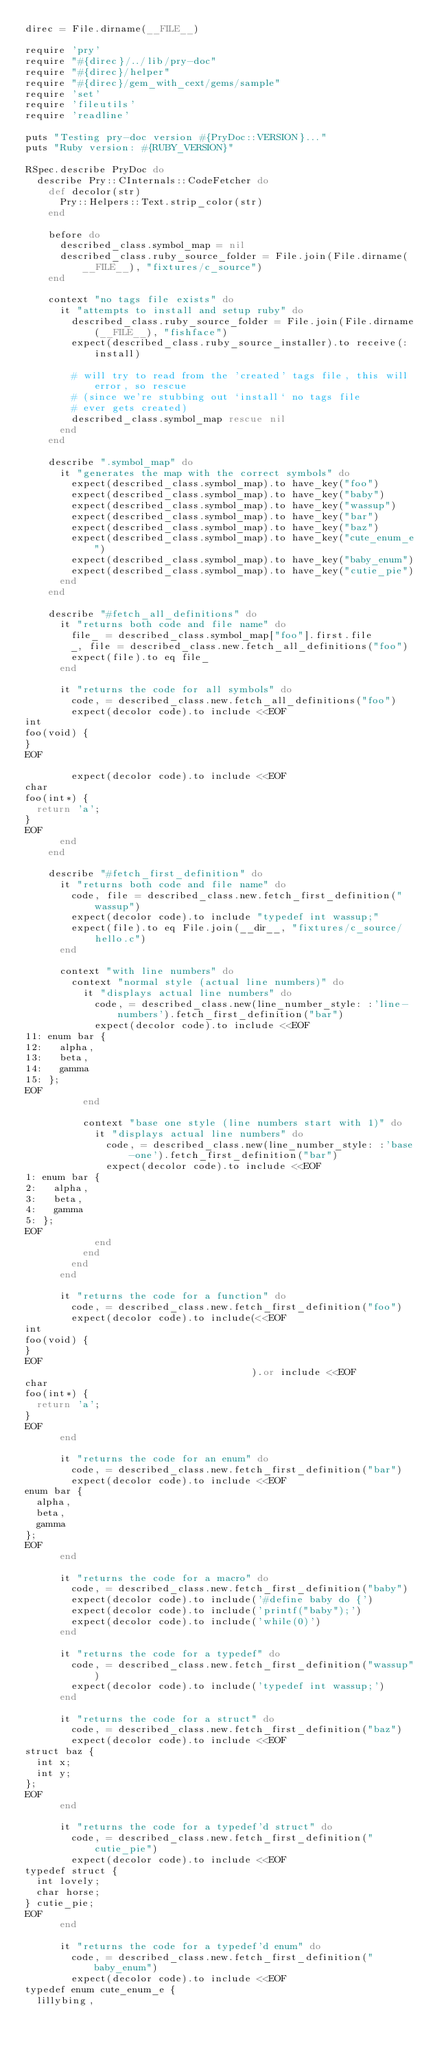<code> <loc_0><loc_0><loc_500><loc_500><_Ruby_>direc = File.dirname(__FILE__)

require 'pry'
require "#{direc}/../lib/pry-doc"
require "#{direc}/helper"
require "#{direc}/gem_with_cext/gems/sample"
require 'set'
require 'fileutils'
require 'readline'

puts "Testing pry-doc version #{PryDoc::VERSION}..."
puts "Ruby version: #{RUBY_VERSION}"

RSpec.describe PryDoc do
  describe Pry::CInternals::CodeFetcher do
    def decolor(str)
      Pry::Helpers::Text.strip_color(str)
    end

    before do
      described_class.symbol_map = nil
      described_class.ruby_source_folder = File.join(File.dirname(__FILE__), "fixtures/c_source")
    end

    context "no tags file exists" do
      it "attempts to install and setup ruby" do
        described_class.ruby_source_folder = File.join(File.dirname(__FILE__), "fishface")
        expect(described_class.ruby_source_installer).to receive(:install)

        # will try to read from the 'created' tags file, this will error, so rescue
        # (since we're stubbing out `install` no tags file
        # ever gets created)
        described_class.symbol_map rescue nil
      end
    end

    describe ".symbol_map" do
      it "generates the map with the correct symbols" do
        expect(described_class.symbol_map).to have_key("foo")
        expect(described_class.symbol_map).to have_key("baby")
        expect(described_class.symbol_map).to have_key("wassup")
        expect(described_class.symbol_map).to have_key("bar")
        expect(described_class.symbol_map).to have_key("baz")
        expect(described_class.symbol_map).to have_key("cute_enum_e")
        expect(described_class.symbol_map).to have_key("baby_enum")
        expect(described_class.symbol_map).to have_key("cutie_pie")
      end
    end

    describe "#fetch_all_definitions" do
      it "returns both code and file name" do
        file_ = described_class.symbol_map["foo"].first.file
        _, file = described_class.new.fetch_all_definitions("foo")
        expect(file).to eq file_
      end

      it "returns the code for all symbols" do
        code, = described_class.new.fetch_all_definitions("foo")
        expect(decolor code).to include <<EOF
int
foo(void) {
}
EOF

        expect(decolor code).to include <<EOF
char
foo(int*) {
  return 'a';
}
EOF
      end
    end

    describe "#fetch_first_definition" do
      it "returns both code and file name" do
        code, file = described_class.new.fetch_first_definition("wassup")
        expect(decolor code).to include "typedef int wassup;"
        expect(file).to eq File.join(__dir__, "fixtures/c_source/hello.c")
      end

      context "with line numbers" do
        context "normal style (actual line numbers)" do
          it "displays actual line numbers" do
            code, = described_class.new(line_number_style: :'line-numbers').fetch_first_definition("bar")
            expect(decolor code).to include <<EOF
11: enum bar {
12:   alpha,
13:   beta,
14:   gamma
15: };
EOF
          end

          context "base one style (line numbers start with 1)" do
            it "displays actual line numbers" do
              code, = described_class.new(line_number_style: :'base-one').fetch_first_definition("bar")
              expect(decolor code).to include <<EOF
1: enum bar {
2:   alpha,
3:   beta,
4:   gamma
5: };
EOF
            end
          end
        end
      end

      it "returns the code for a function" do
        code, = described_class.new.fetch_first_definition("foo")
        expect(decolor code).to include(<<EOF
int
foo(void) {
}
EOF
                                       ).or include <<EOF
char
foo(int*) {
  return 'a';
}
EOF
      end

      it "returns the code for an enum" do
        code, = described_class.new.fetch_first_definition("bar")
        expect(decolor code).to include <<EOF
enum bar {
  alpha,
  beta,
  gamma
};
EOF
      end

      it "returns the code for a macro" do
        code, = described_class.new.fetch_first_definition("baby")
        expect(decolor code).to include('#define baby do {')
        expect(decolor code).to include('printf("baby");')
        expect(decolor code).to include('while(0)')
      end

      it "returns the code for a typedef" do
        code, = described_class.new.fetch_first_definition("wassup")
        expect(decolor code).to include('typedef int wassup;')
      end

      it "returns the code for a struct" do
        code, = described_class.new.fetch_first_definition("baz")
        expect(decolor code).to include <<EOF
struct baz {
  int x;
  int y;
};
EOF
      end

      it "returns the code for a typedef'd struct" do
        code, = described_class.new.fetch_first_definition("cutie_pie")
        expect(decolor code).to include <<EOF
typedef struct {
  int lovely;
  char horse;
} cutie_pie;
EOF
      end

      it "returns the code for a typedef'd enum" do
        code, = described_class.new.fetch_first_definition("baby_enum")
        expect(decolor code).to include <<EOF
typedef enum cute_enum_e {
  lillybing,</code> 